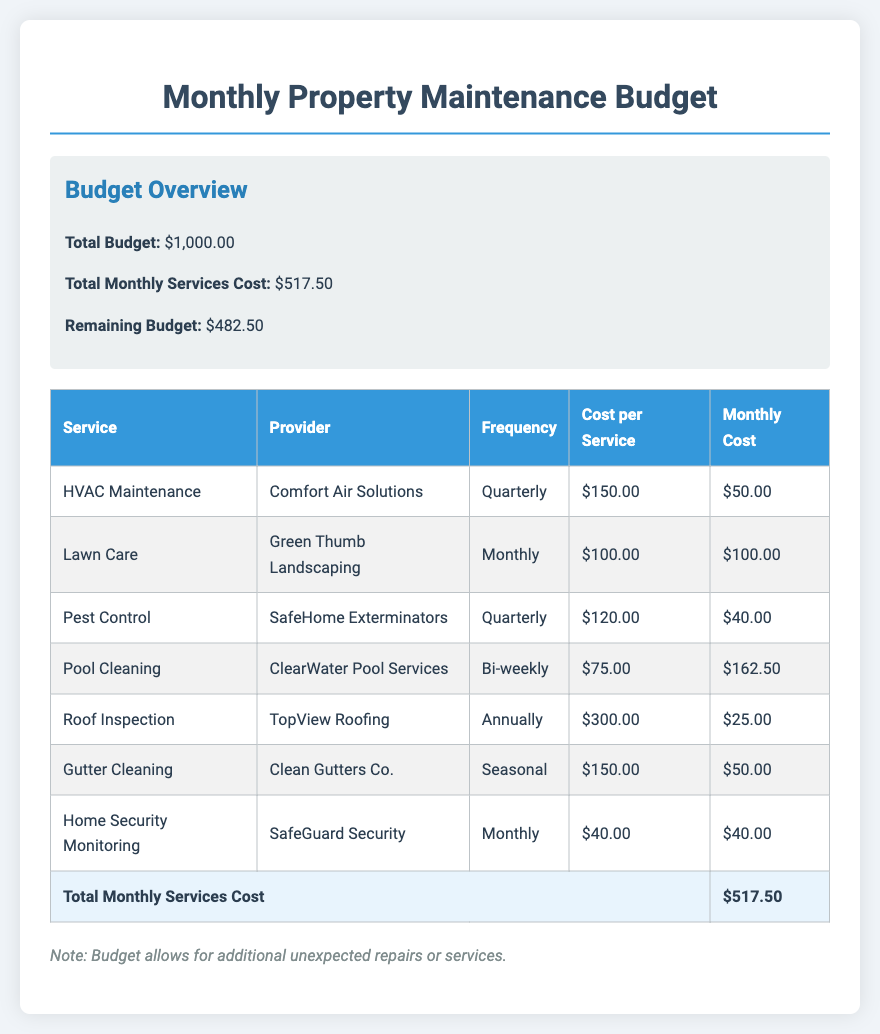What is the total budget? The total budget is clearly stated in the document, which is $1,000.00.
Answer: $1,000.00 How much is allocated for lawn care? The document lists the monthly cost for lawn care, which is $100.00.
Answer: $100.00 Who provides pest control services? The name of the pest control service provider can be found in the document, which is SafeHome Exterminators.
Answer: SafeHome Exterminators What is the frequency of roof inspections? The document explains that roof inspections are conducted annually.
Answer: Annually What is the total monthly services cost? The total monthly services cost is summed up in the document, which is $517.50.
Answer: $517.50 Which service is the most frequent? The document indicates that lawn care is provided monthly, making it the most frequent service.
Answer: Monthly What is the remaining budget after monthly costs? The remaining budget is calculated by subtracting the total monthly services cost from the total budget, which is $482.50.
Answer: $482.50 How much is charged for home security monitoring? The document states the monthly cost for home security monitoring is $40.00.
Answer: $40.00 What is the cost per service for HVAC maintenance? The document specifies that the cost per service for HVAC maintenance is $150.00.
Answer: $150.00 